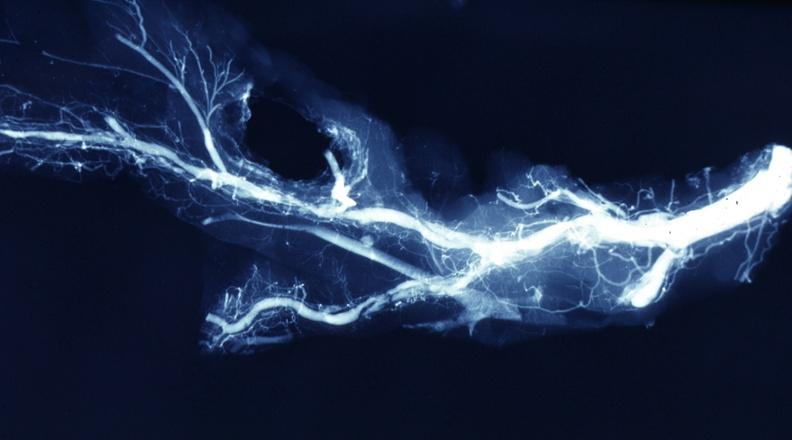what does this image show?
Answer the question using a single word or phrase. X-ray postmortdissected artery lesions in small branches 